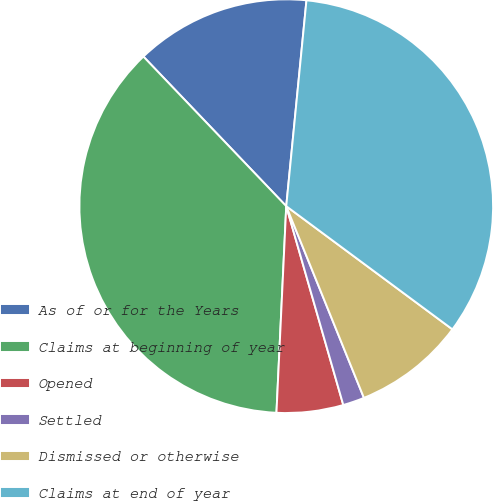<chart> <loc_0><loc_0><loc_500><loc_500><pie_chart><fcel>As of or for the Years<fcel>Claims at beginning of year<fcel>Opened<fcel>Settled<fcel>Dismissed or otherwise<fcel>Claims at end of year<nl><fcel>13.69%<fcel>37.11%<fcel>5.2%<fcel>1.68%<fcel>8.72%<fcel>33.59%<nl></chart> 